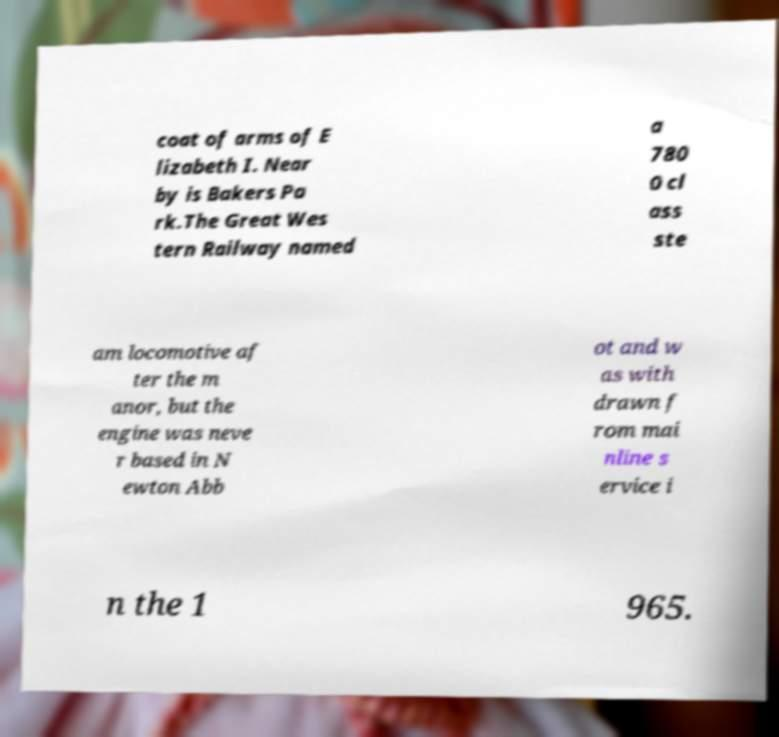Can you read and provide the text displayed in the image?This photo seems to have some interesting text. Can you extract and type it out for me? coat of arms of E lizabeth I. Near by is Bakers Pa rk.The Great Wes tern Railway named a 780 0 cl ass ste am locomotive af ter the m anor, but the engine was neve r based in N ewton Abb ot and w as with drawn f rom mai nline s ervice i n the 1 965. 